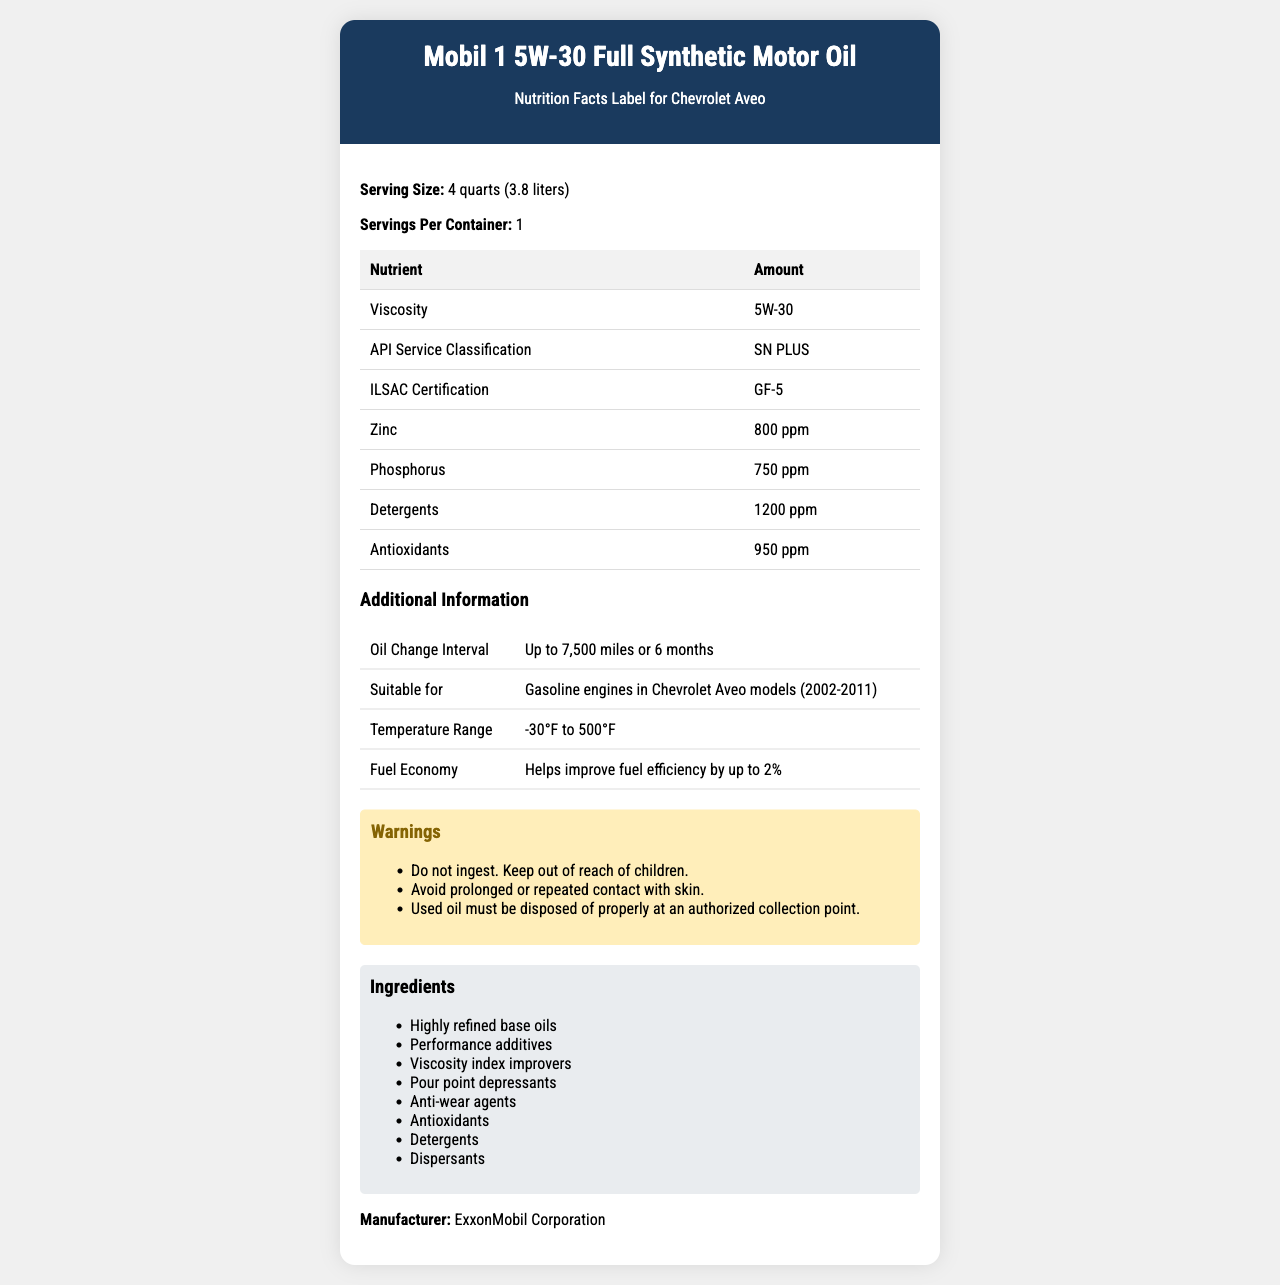what is the serving size of Mobil 1 5W-30 Full Synthetic Motor Oil? The serving size is mentioned at the beginning of the document under the section "Serving Size."
Answer: 4 quarts (3.8 liters) how often should you change the oil in your Chevrolet Aveo when using Mobil 1 5W-30 Full Synthetic Motor Oil? This information is found in the "Additional Information" section under "Oil Change Interval."
Answer: Up to 7,500 miles or 6 months what is the viscosity rating of this motor oil? The viscosity rating is listed in the "Nutrient Facts" section under "Viscosity."
Answer: 5W-30 how much zinc is present in Mobil 1 5W-30 Full Synthetic Motor Oil? The amount of zinc is listed in the "Nutrient Facts" section under "Zinc."
Answer: 800 ppm who manufactures Mobil 1 5W-30 Full Synthetic Motor Oil? The manufacturer information is found at the end of the document under "Manufacturer."
Answer: ExxonMobil Corporation which of the following engines is Mobil 1 5W-30 Full Synthetic Motor Oil suitable for? A. Diesel engines B. Gasoline engines in Chevrolet Aveo models (2002-2011) C. Hybrid engines According to the "Additional Information," it is suitable for "Gasoline engines in Chevrolet Aveo models (2002-2011)."
Answer: B which certification does Mobil 1 5W-30 Full Synthetic Motor Oil have? A. API Service Classification: SN PLUS B. ILSAC Certification: GF-5 C. Both A and B The document shows that it has both the API Service Classification: SN PLUS and ILSAC Certification: GF-5.
Answer: C should you ingest Mobil 1 5W-30 Full Synthetic Motor Oil? The warnings section clearly states, "Do not ingest."
Answer: No can Mobil 1 5W-30 Full Synthetic Motor Oil improve fuel efficiency? The "Additional Information" section states that it helps improve fuel efficiency by up to 2%.
Answer: Yes which ingredient is not listed in the document for Mobil 1 5W-30 Full Synthetic Motor Oil? The document does not provide information on what ingredients are not included, only on what ingredients are present.
Answer: Cannot be determined summarize the main information provided about Mobil 1 5W-30 Full Synthetic Motor Oil. The document provides detailed information including the product name, suitable applications, certifications, key ingredients and their amounts, oil change intervals, temperature range, fuel economy benefits, and warnings.
Answer: Mobil 1 5W-30 Full Synthetic Motor Oil is a motor oil suitable for gasoline engines in Chevrolet Aveo models (2002-2011). It comes in a serving size of 4 quarts (3.8 liters) and has certifications including API Service Classification SN PLUS and ILSAC GF-5. The oil contains various additives such as zinc, phosphorus, detergents, and antioxidants, and is manufactured by ExxonMobil Corporation. Additional information includes oil change intervals of up to 7,500 miles or 6 months, a temperature range of -30°F to 500°F, and it helps improve fuel efficiency by up to 2%. Warnings include not ingesting the oil and ensuring used oil is disposed of properly. 